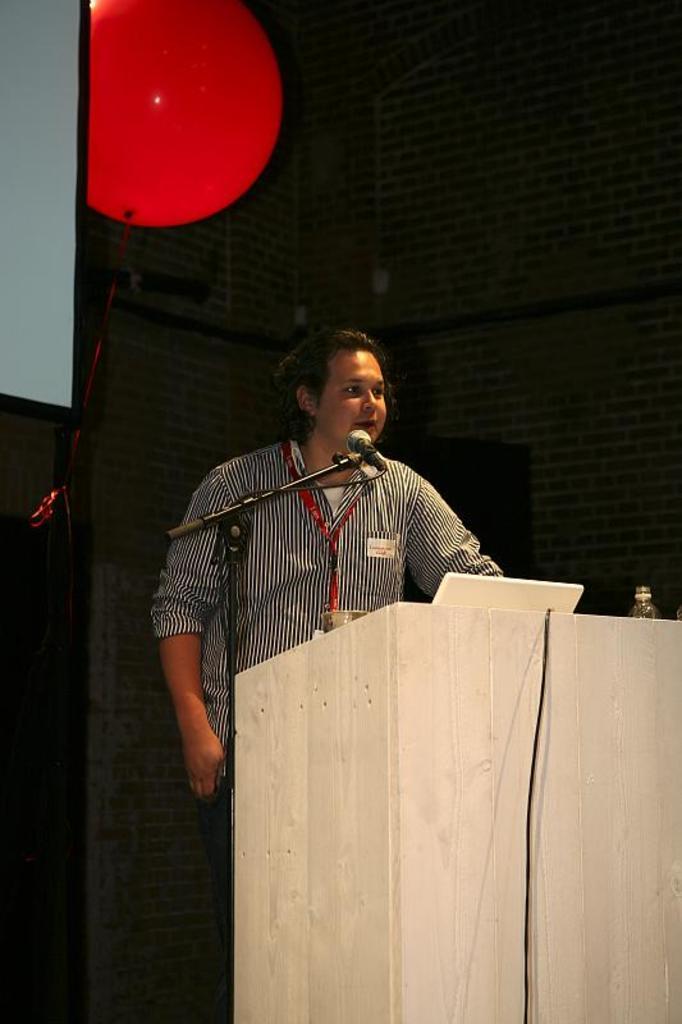In one or two sentences, can you explain what this image depicts? In this picture I can observe a person standing in front of a podium. There is a mic and a stand in front of a person. On the left side I can observe a screen. There is a red color balloon beside the screen. In the background there is a wall. 